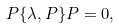<formula> <loc_0><loc_0><loc_500><loc_500>P \{ \lambda , P \} P = 0 ,</formula> 